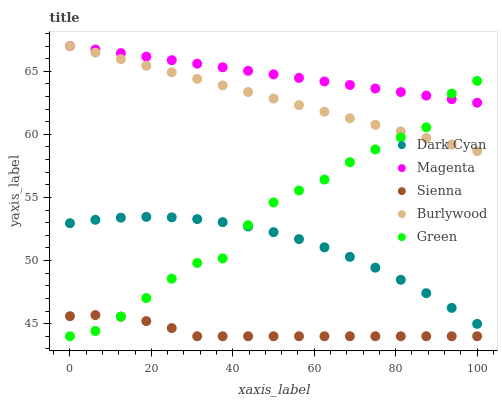Does Sienna have the minimum area under the curve?
Answer yes or no. Yes. Does Magenta have the maximum area under the curve?
Answer yes or no. Yes. Does Magenta have the minimum area under the curve?
Answer yes or no. No. Does Sienna have the maximum area under the curve?
Answer yes or no. No. Is Magenta the smoothest?
Answer yes or no. Yes. Is Green the roughest?
Answer yes or no. Yes. Is Sienna the smoothest?
Answer yes or no. No. Is Sienna the roughest?
Answer yes or no. No. Does Sienna have the lowest value?
Answer yes or no. Yes. Does Magenta have the lowest value?
Answer yes or no. No. Does Burlywood have the highest value?
Answer yes or no. Yes. Does Sienna have the highest value?
Answer yes or no. No. Is Dark Cyan less than Magenta?
Answer yes or no. Yes. Is Burlywood greater than Dark Cyan?
Answer yes or no. Yes. Does Burlywood intersect Magenta?
Answer yes or no. Yes. Is Burlywood less than Magenta?
Answer yes or no. No. Is Burlywood greater than Magenta?
Answer yes or no. No. Does Dark Cyan intersect Magenta?
Answer yes or no. No. 